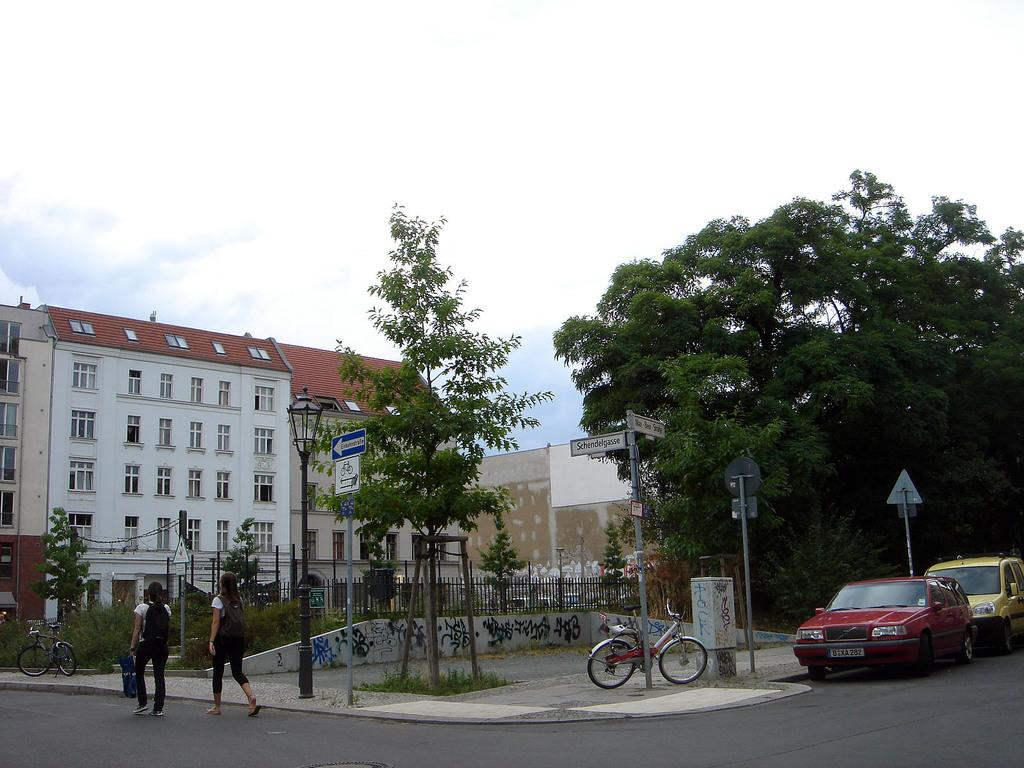What type of structure is present in the image? There is a building in the image. What are the vertical supports in the image? There are poles in the image. What type of information is displayed in the image? There are sign boards in the image. What type of vegetation is present in the image? There are trees and plants in the image. What type of transportation is present in the image? There are vehicles in the image. Are there any human figures in the image? Yes, there are people in the image. What type of barrier is present in the image? There is a fence in the image. What can be seen in the background of the image? The sky is visible in the background of the image. What type of pickle is being sold at the building in the image? There is no mention of pickles or any food items being sold in the image. How does love manifest itself in the image? The image does not depict any emotions or feelings, including love. 